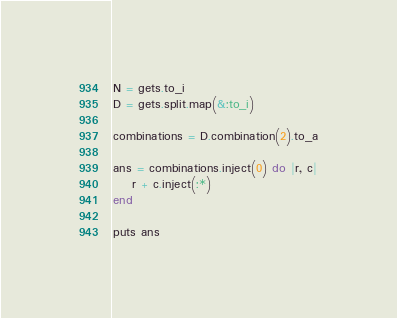Convert code to text. <code><loc_0><loc_0><loc_500><loc_500><_Ruby_>N = gets.to_i
D = gets.split.map(&:to_i)

combinations = D.combination(2).to_a

ans = combinations.inject(0) do |r, c|
    r + c.inject(:*)
end

puts ans</code> 